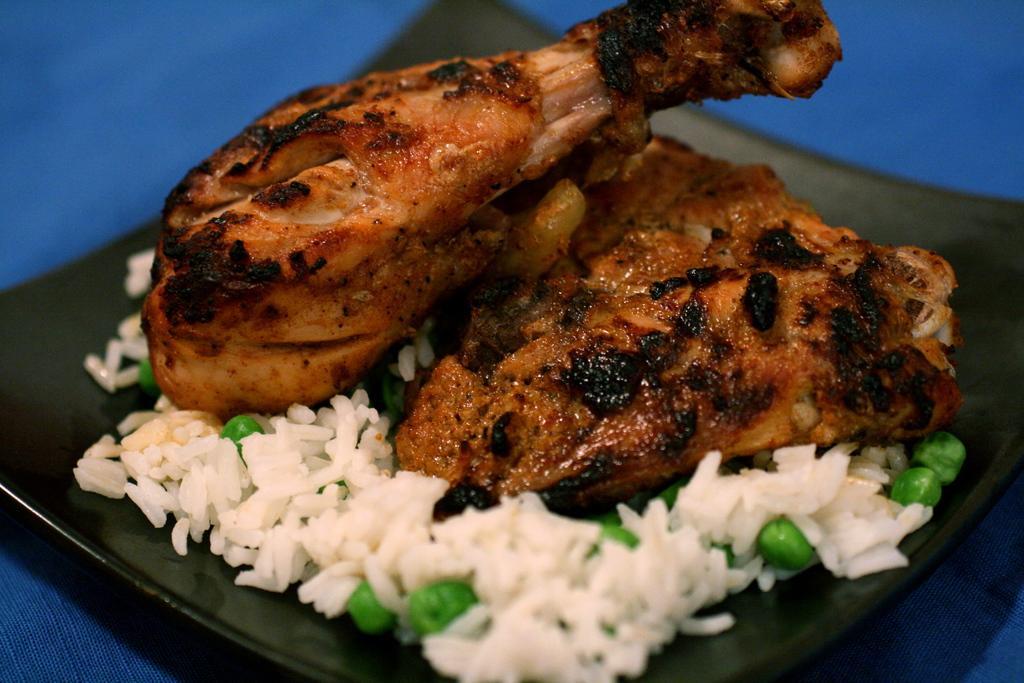Could you give a brief overview of what you see in this image? In this image we can see food placed on a plate. 